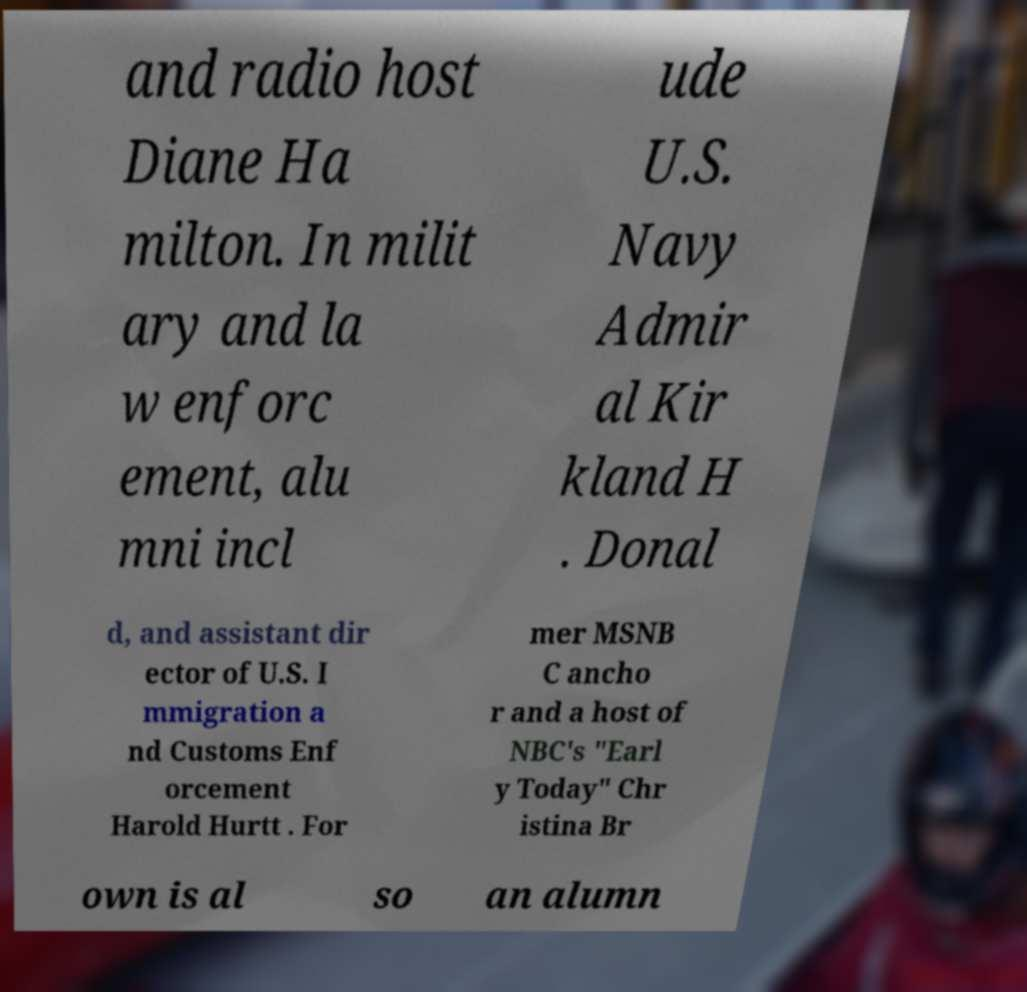Can you accurately transcribe the text from the provided image for me? and radio host Diane Ha milton. In milit ary and la w enforc ement, alu mni incl ude U.S. Navy Admir al Kir kland H . Donal d, and assistant dir ector of U.S. I mmigration a nd Customs Enf orcement Harold Hurtt . For mer MSNB C ancho r and a host of NBC's "Earl y Today" Chr istina Br own is al so an alumn 